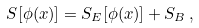<formula> <loc_0><loc_0><loc_500><loc_500>S [ \phi ( x ) ] = S _ { E } [ \phi ( x ) ] + S _ { B } \, ,</formula> 